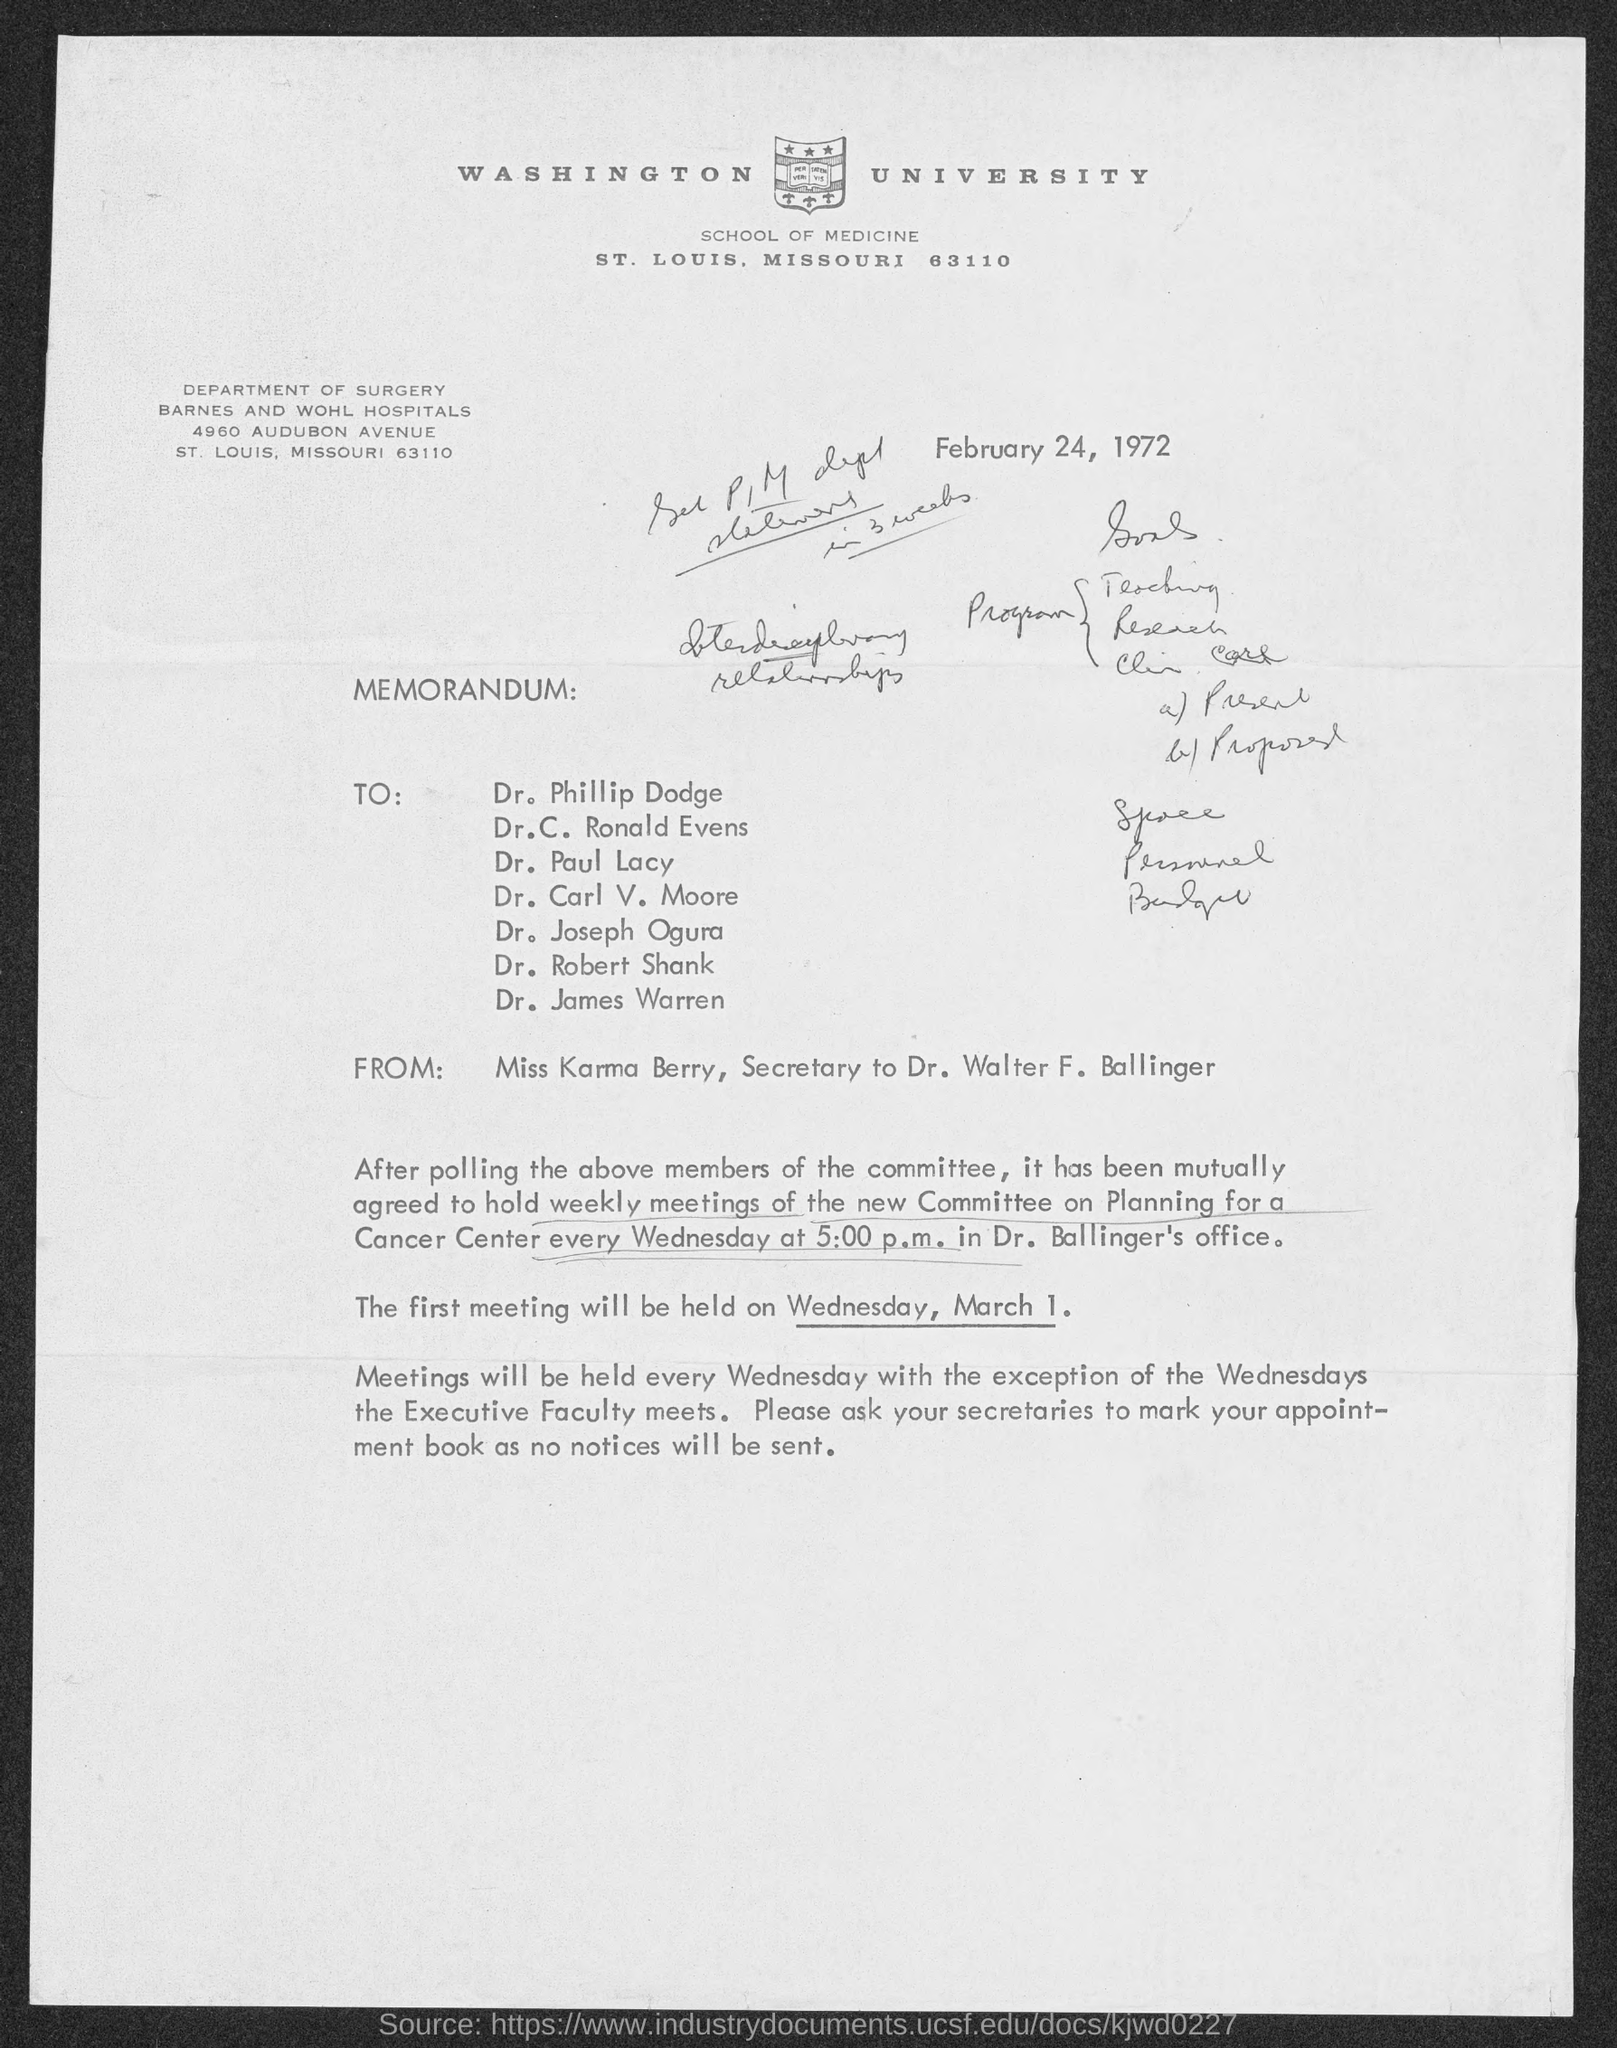What is the street address of barnes and wohl hospitals ?
Make the answer very short. 4960 Audubon Avenue. When is the memorandum dated?
Keep it short and to the point. February 24, 1972. 